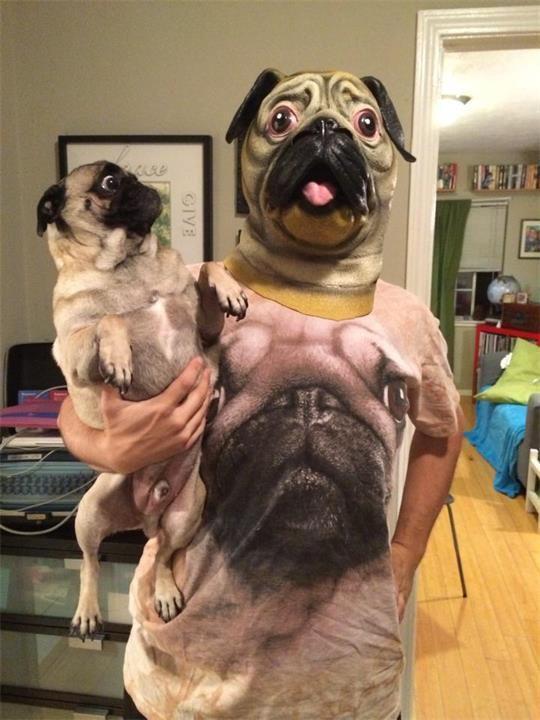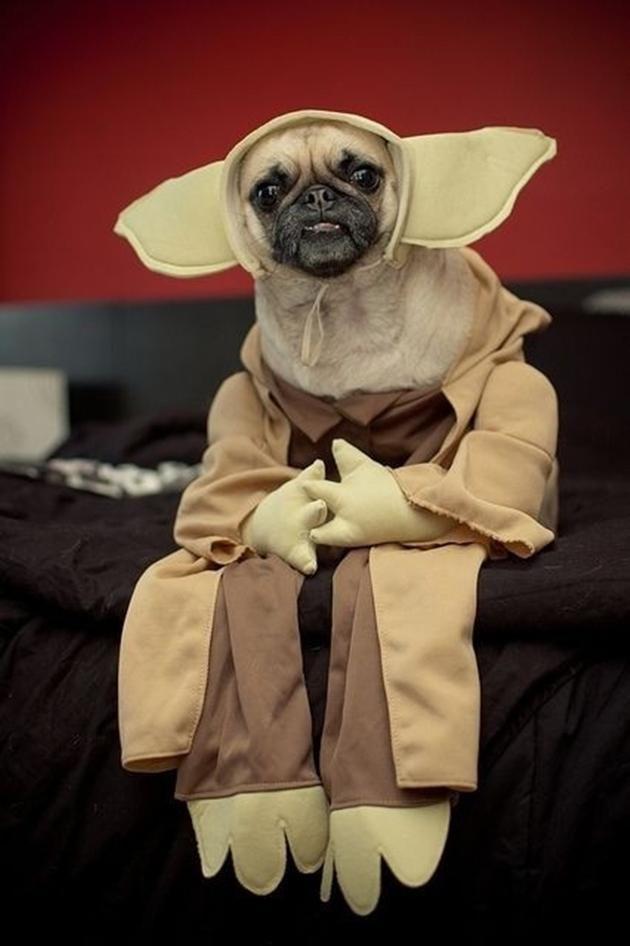The first image is the image on the left, the second image is the image on the right. For the images shown, is this caption "One of the dogs shown is wearing a hat with a brim." true? Answer yes or no. No. 